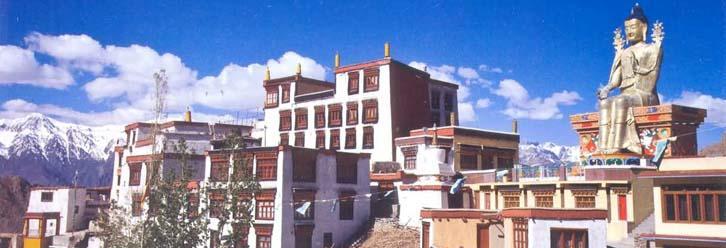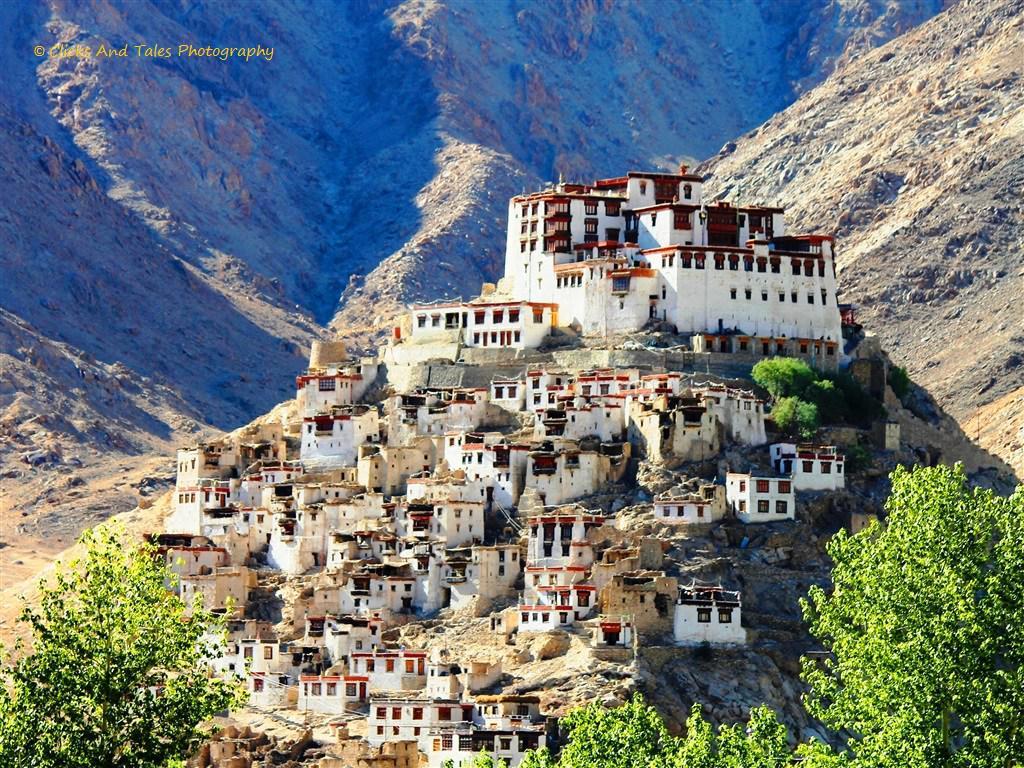The first image is the image on the left, the second image is the image on the right. Given the left and right images, does the statement "A statue of a seated human figure is visible amid flat-roofed buildings." hold true? Answer yes or no. Yes. 